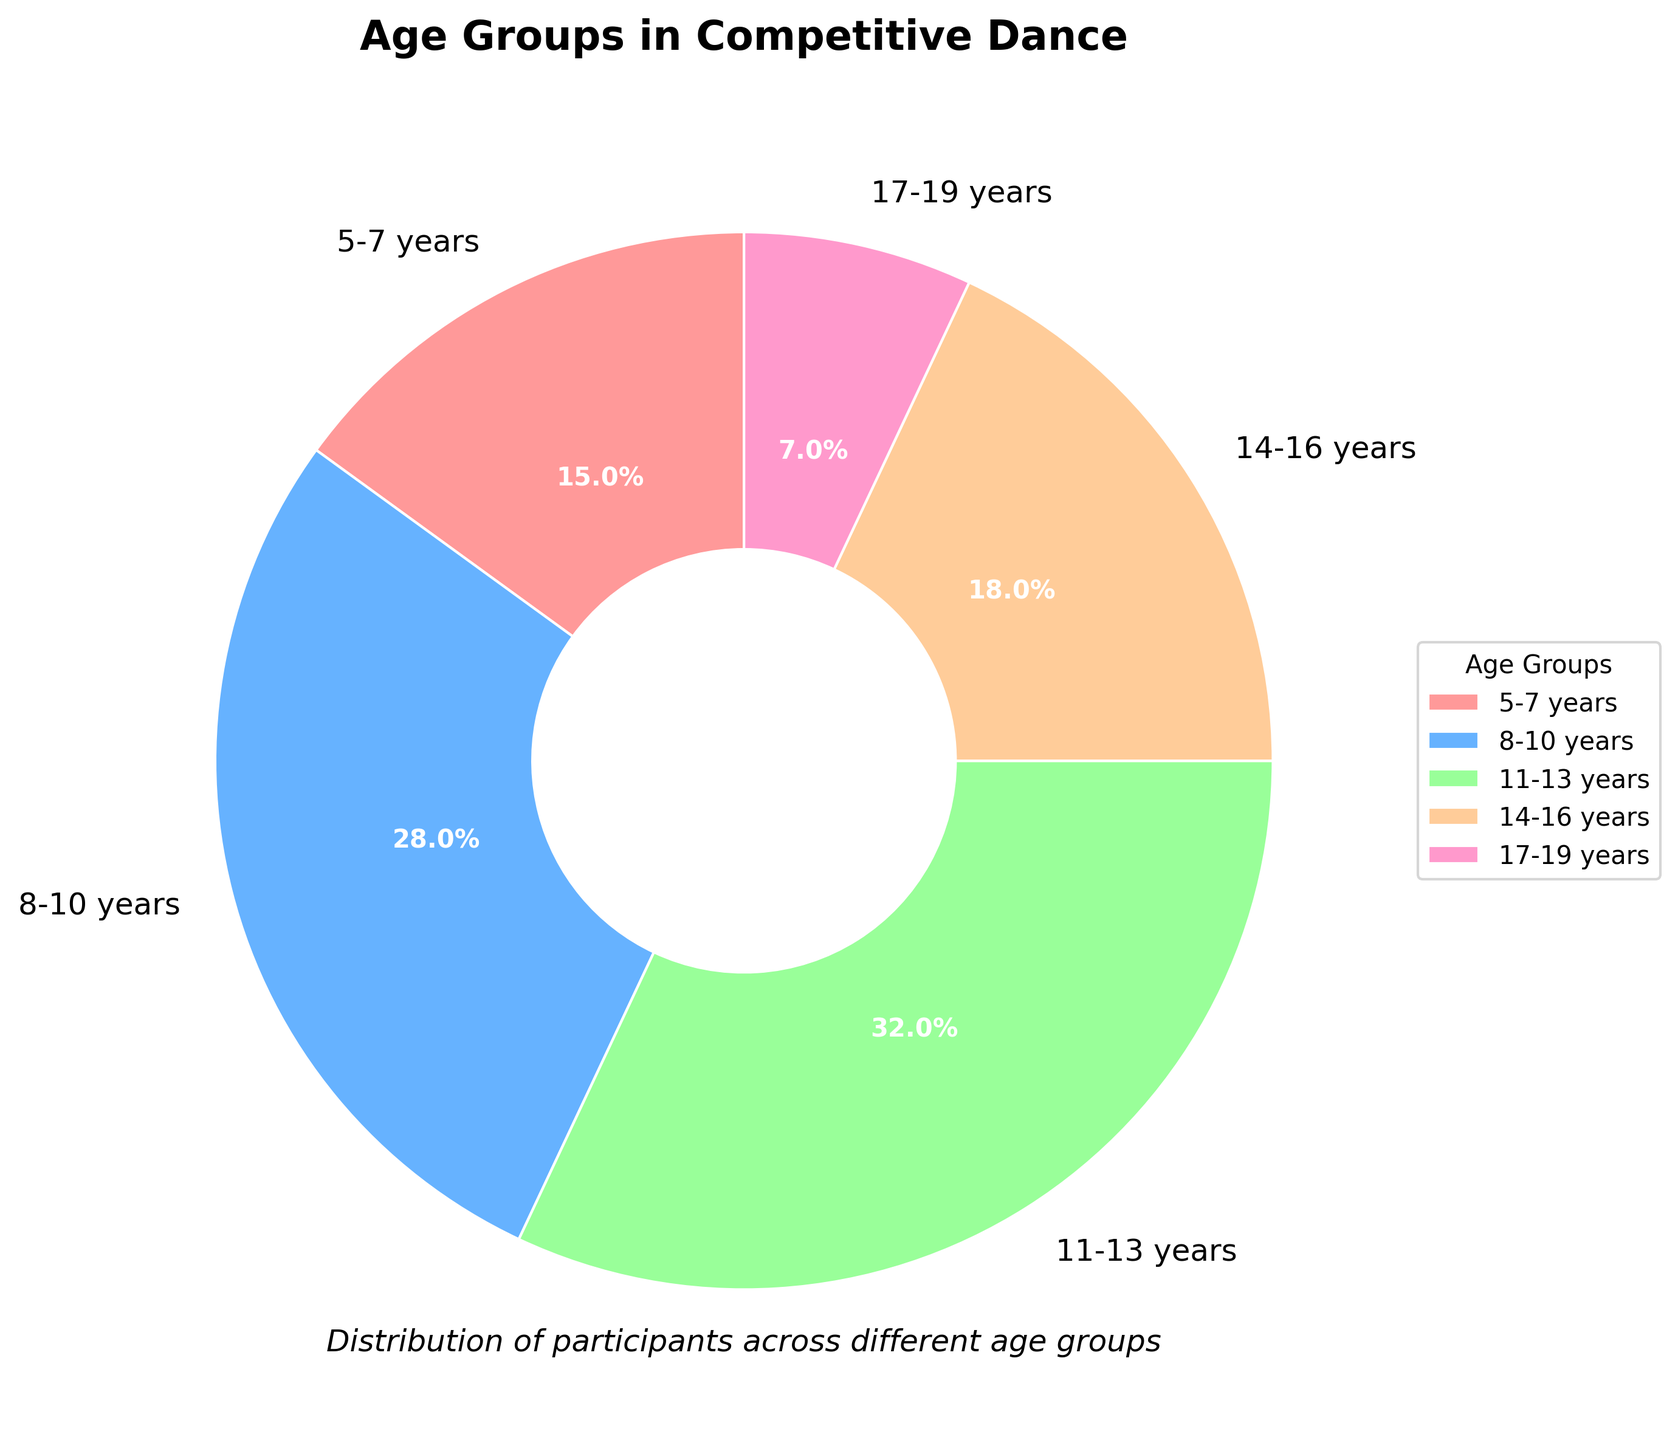What age group has the largest percentage of children involved in competitive dance? The pie chart shows the different age groups and their respective percentages. The age group with the largest percentage has the highest numerical value associated with it. In this case, the 11-13 years age group has the highest percentage at 32%.
Answer: 11-13 years Which age group has the least representation in competitive dance? By examining the percentages allocated to each age group in the pie chart, the age group with the smallest percentage will be the least represented. Here, the 17-19 years age group has the smallest percentage at 7%.
Answer: 17-19 years What is the total percentage of children involved in competitive dance aged 14-19 years? Sum the percentages of the 14-16 years and 17-19 years age groups to get the total percentage. The values are 18% (14-16 years) + 7% (17-19 years) = 25%.
Answer: 25% How much larger is the percentage of children aged 8-10 years compared to those aged 5-7 years? The percentage for the 8-10 years age group is 28%, and for the 5-7 years age group, it is 15%. The difference is calculated as 28% - 15% = 13%.
Answer: 13% What is the ratio of children in the 11-13 years age group to those in the 5-7 years age group? The percentage of the 11-13 years age group is 32%, and the percentage of the 5-7 years age group is 15%. The ratio is calculated as 32% / 15% = 2.13 (approximately).
Answer: 2.13 If combining the three smallest age groups, what is their combined percentage? The three smallest age groups are 17-19 years (7%), 14-16 years (18%), and 5-7 years (15%). The combined percentage is calculated as 7% + 18% + 15% = 40%.
Answer: 40% How many more percentage points do children in the 11-13 years age group represent compared to the 14-16 years age group? The percentage for the 11-13 years age group is 32%, and for the 14-16 years age group, it is 18%. The difference in percentage points is calculated as 32% - 18% = 14%.
Answer: 14% 